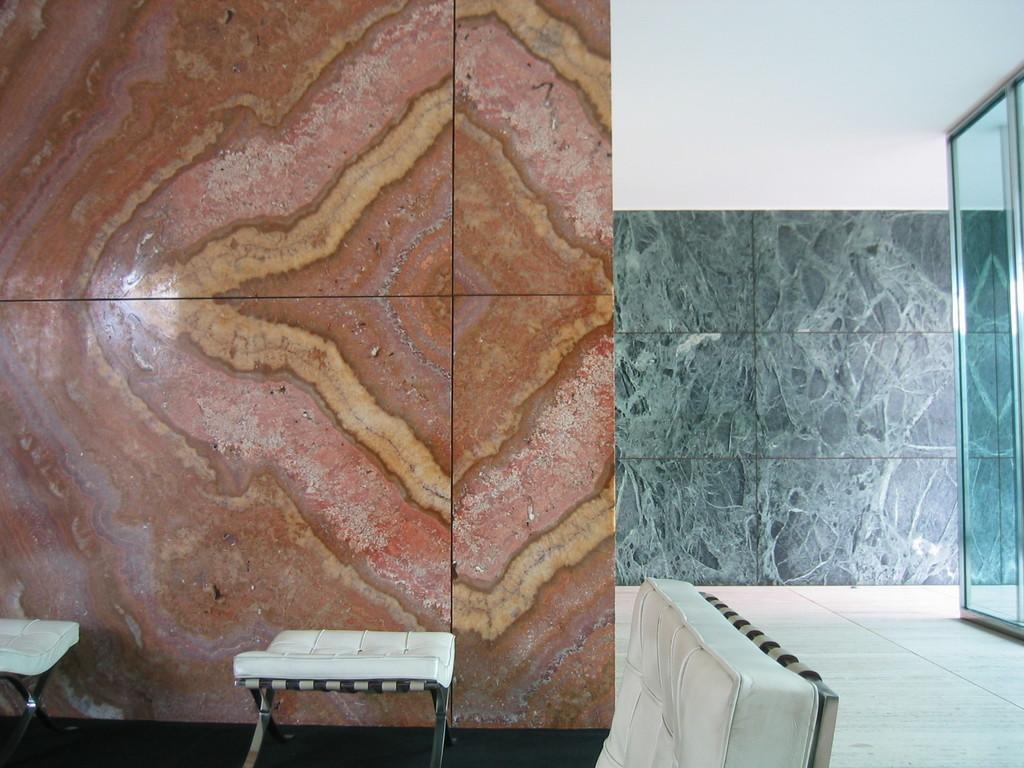Can you describe this image briefly? In this picture I can see a chair and looks like couple of stools and I can see a wall in the background and looks like a inner view of a room and I can see glass on the right side. 